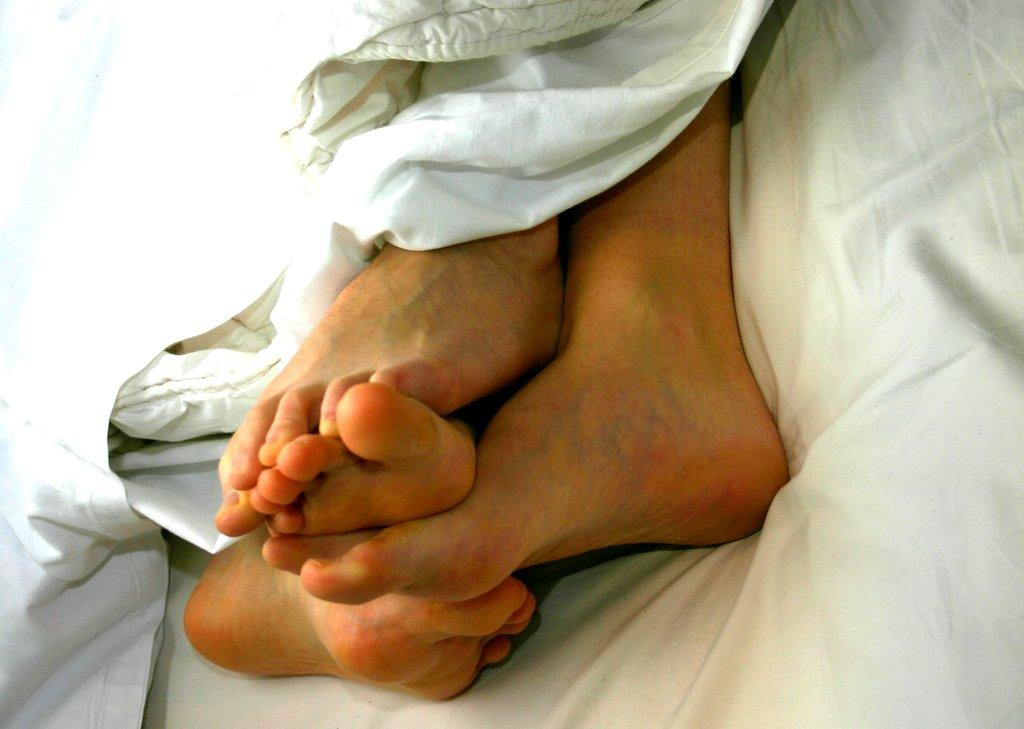What body parts are visible in the image? There are person's legs in the image. What color are the clothes of the person in the image? The clothes are white in the image. How much profit did the person make from using the rake in the image? There is no rake or indication of profit in the image. 